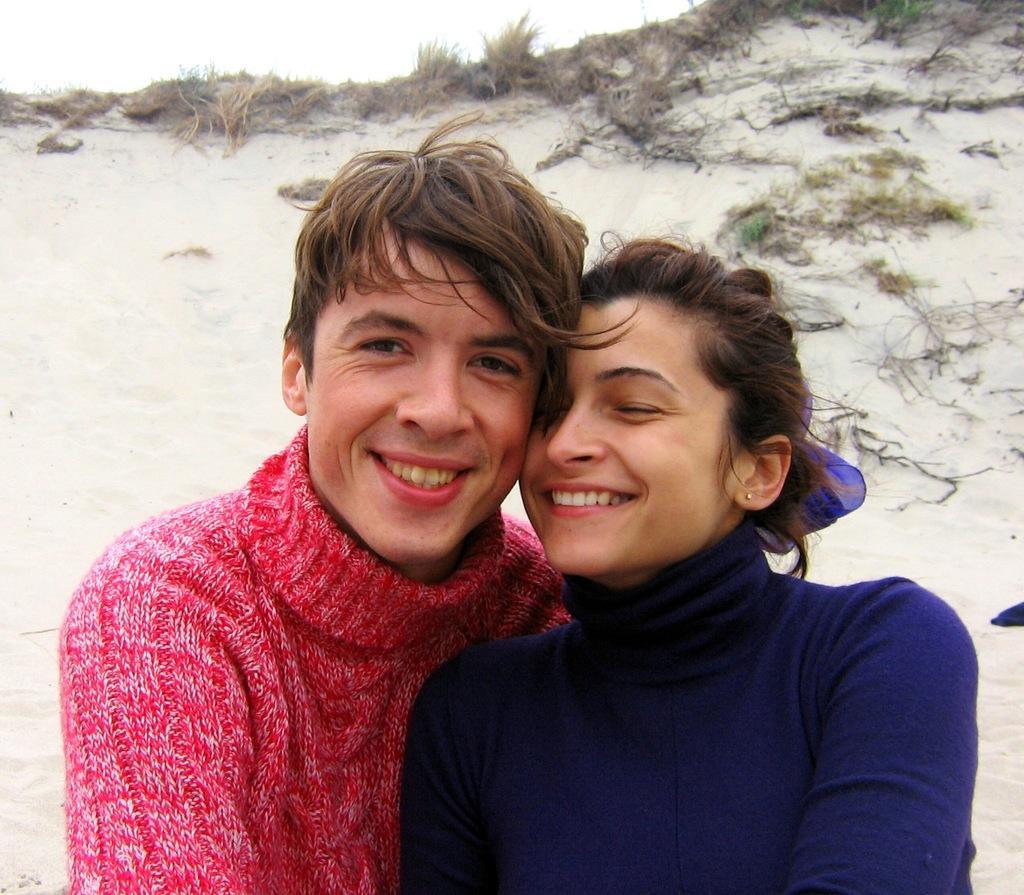Can you describe this image briefly? In this image we can see two persons smiling, behind them, we can see some plants and grass, in the background we can see the sky. 